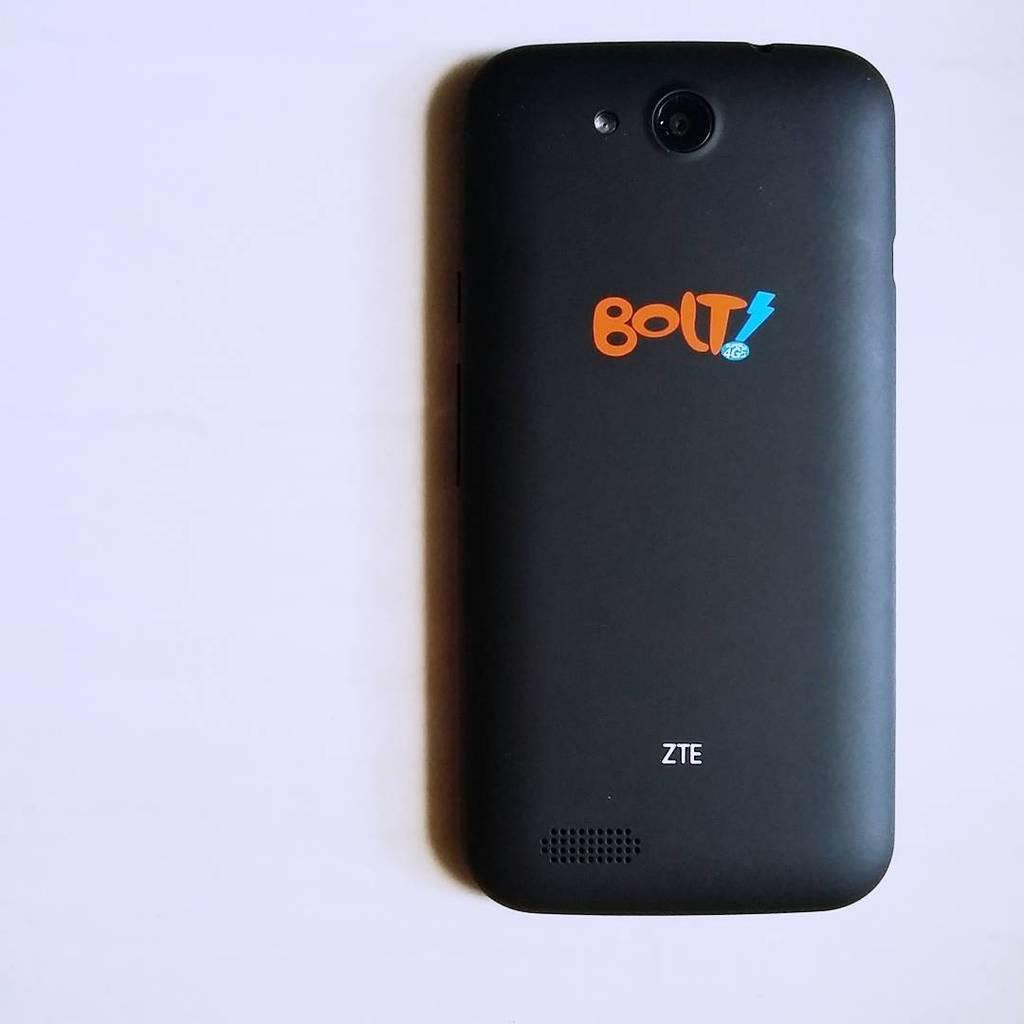<image>
Relay a brief, clear account of the picture shown. The back of a Bolt ZTE cell phone is lying on a light purple surface. 